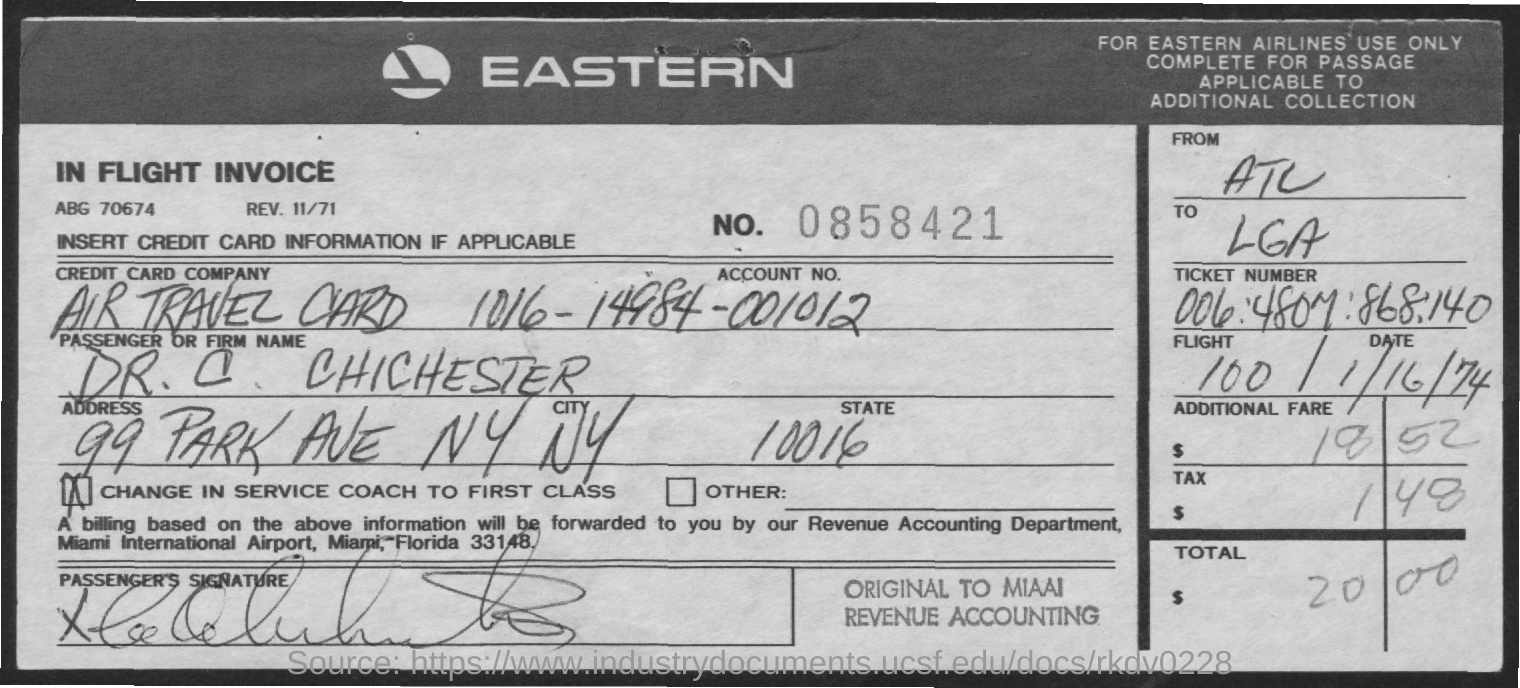Outline some significant characteristics in this image. The Passenger or Firm name is Dr. C. Chichester. The address is 99 Park Avenue, New York. The account number is 1016-14984-001012. There is a credit card company that offers an Air Travel Card. 